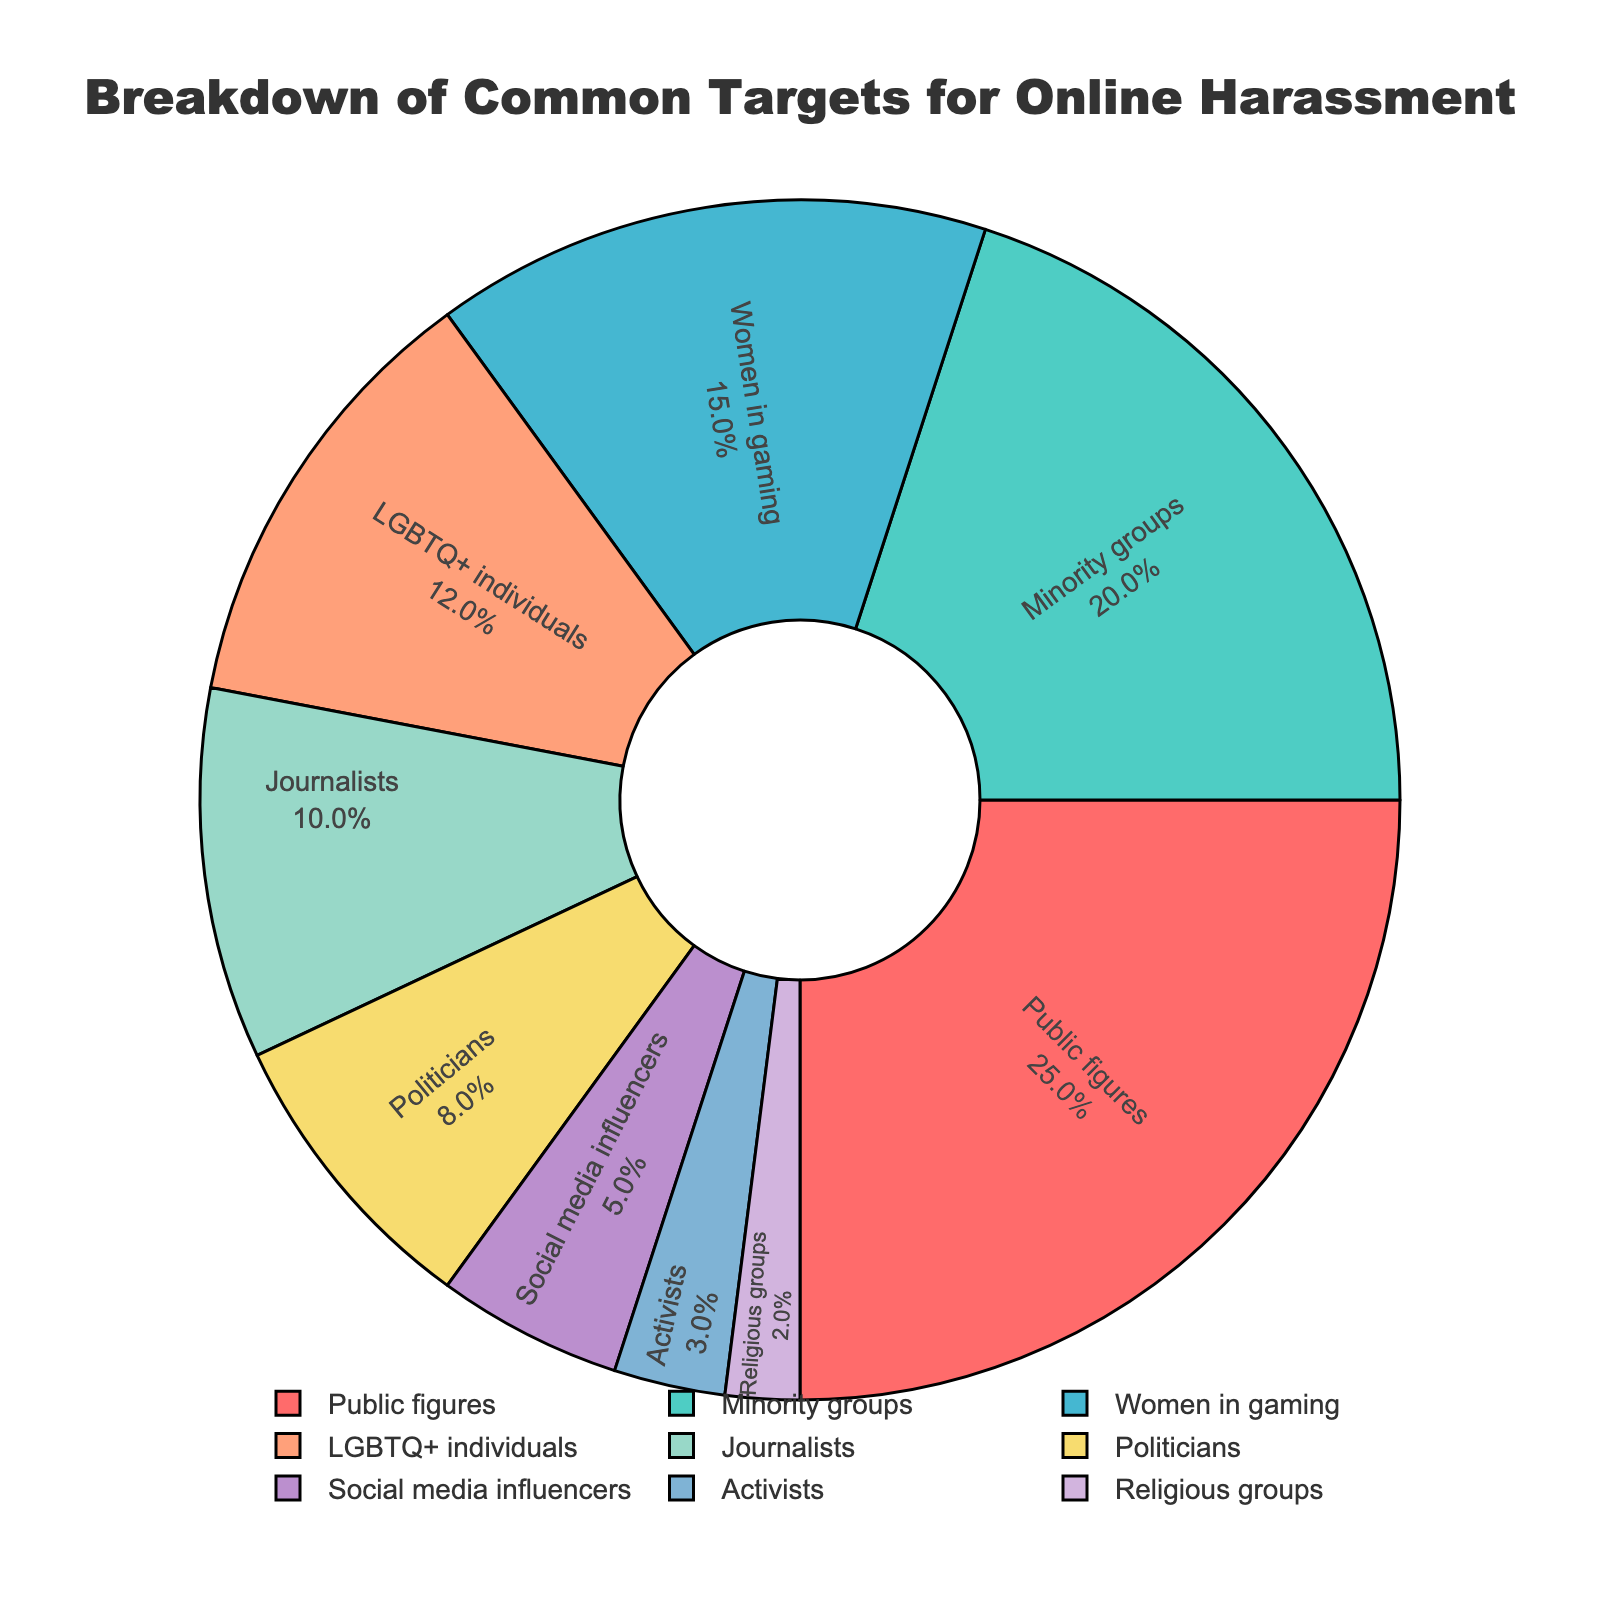Which group has the highest percentage? The group with the highest percentage is indicated by the largest slice of the pie chart. "Public figures" have the largest slice with 25%.
Answer: Public figures Which target group has twice the percentage of social media influencers? Social media influencers have 5%. Doubling this amount gives 10%. "Journalists" have exactly 10%.
Answer: Journalists What is the combined percentage of Women in gaming, LGBTQ+ individuals, and Journalists? Add the percentages of Women in gaming (15%), LGBTQ+ individuals (12%), and Journalists (10%). Calculating this gives 15 + 12 + 10 = 37%.
Answer: 37% Which group has the lowest percentage? The smallest slice in the pie chart represents the group with the lowest percentage. "Religious groups" have the smallest slice with 2%.
Answer: Religious groups How does the percentage of Minority groups compare to that of Politicians? Minority groups have 20%, while Politicians have 8%. Minority groups have a higher percentage than Politicians.
Answer: Minority groups have a higher percentage What is the percentage difference between Public figures and Women in gaming? Subtract the percentage of Women in gaming (15%) from the percentage of Public figures (25%). The calculation is 25 - 15 = 10%.
Answer: 10% How many groups have a percentage less than 10%? Groups with a percentage less than 10% are Politicians (8%), Social media influencers (5%), Activists (3%), and Religious groups (2%). There are 4 such groups.
Answer: 4 What is the combined percentage of Public figures, Minority groups, and Politicians? Add the percentages of Public figures (25%), Minority groups (20%), and Politicians (8%). The calculation is 25 + 20 + 8 = 53%.
Answer: 53% Are Women in gaming or LGBTQ+ individuals targeted more frequently? Women in gaming have a percentage of 15%, while LGBTQ+ individuals have 12%. Women in gaming are targeted more frequently.
Answer: Women in gaming 